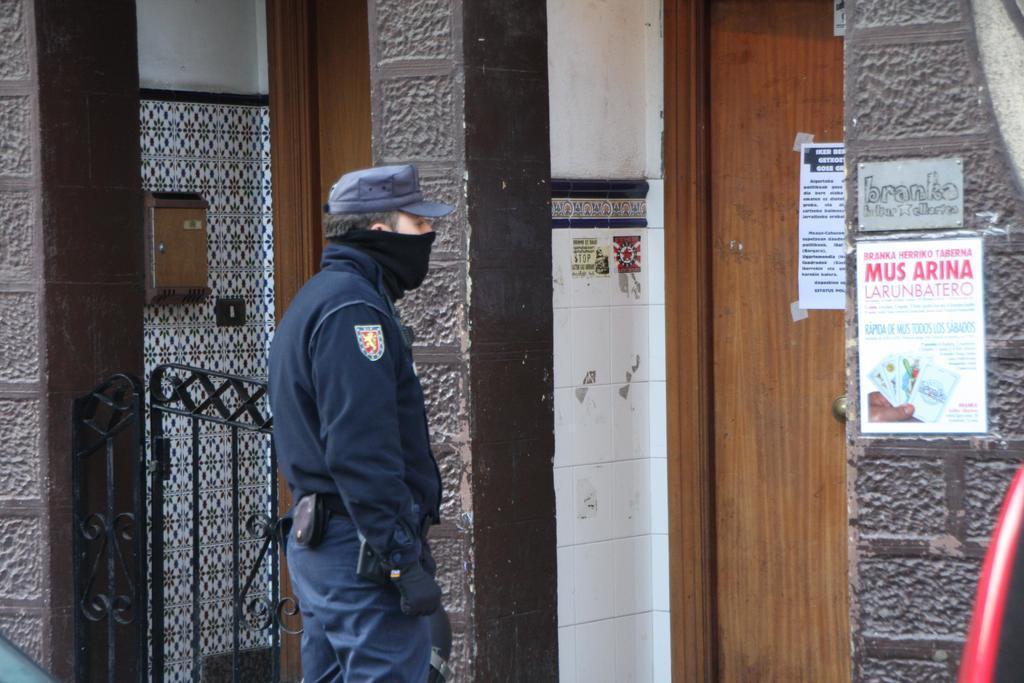Could you give a brief overview of what you see in this image? To these wall and door there are posters. Here we can see gate. A person is standing and wore cap. Box is attached to this tile wall. 